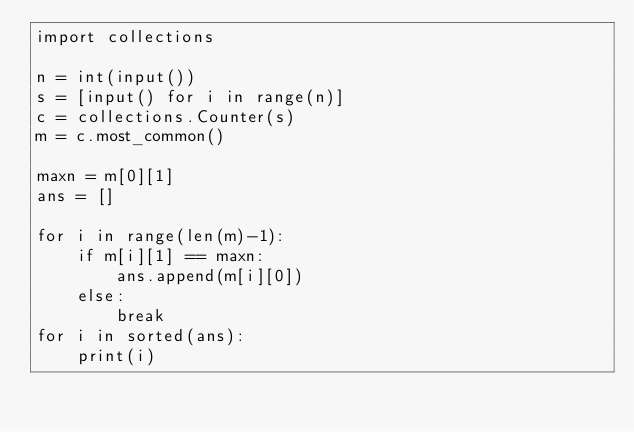Convert code to text. <code><loc_0><loc_0><loc_500><loc_500><_Python_>import collections

n = int(input())
s = [input() for i in range(n)]
c = collections.Counter(s)
m = c.most_common()

maxn = m[0][1]
ans = []

for i in range(len(m)-1):
    if m[i][1] == maxn:
        ans.append(m[i][0])
    else:
        break
for i in sorted(ans):
    print(i)
</code> 